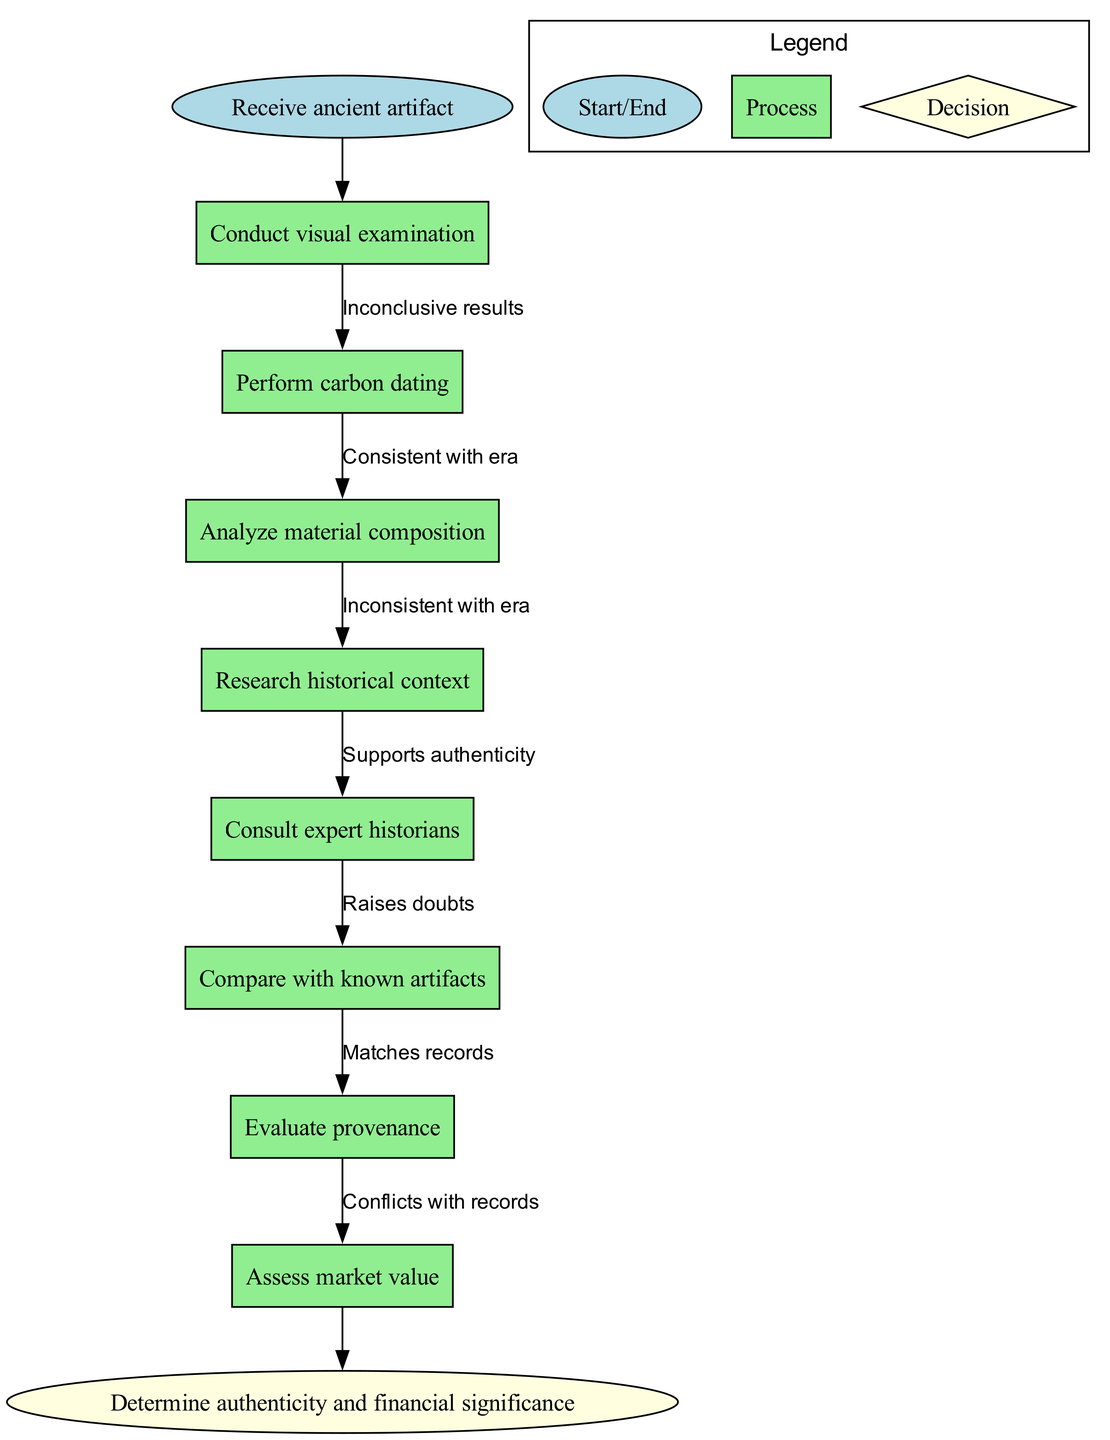What is the first step in the process? The first step in the process is indicated by the start node, which states "Receive ancient artifact." It is the initial action before any analysis can begin.
Answer: Receive ancient artifact How many process nodes are there? By counting the nodes listed in the diagram, we find eight process nodes. Each process represents a different aspect of the research methodology necessary for authenticating artifacts.
Answer: 8 What edges connect "Conduct visual examination" to "Perform carbon dating"? The edges show the relationship between nodes; however, in this flowchart, there is a direct connection from "Conduct visual examination" to the next process "Perform carbon dating" without a labeled edge because it follows consecutively in the steps. Thus, we infer it's a straightforward transition in the procedure.
Answer: Direct connection What would indicate "Inconsistent with era" in the flowchart? The term "Inconsistent with era" appears as an edge label that connects the nodes. It's part of the decision-making process where findings from an analysis raise doubts about the artifact's authenticity.
Answer: Inconsistent with era If the analysis "Raises doubts," which node does the flow lead to next? The flow from "Raises doubts" would typically lead to "Evaluate provenance," as it suggests further scrutiny of the artifact's background is necessary to determine authenticity, due to inconsistencies found.
Answer: Evaluate provenance What is the final outcome depicted in the flowchart? The final outcome node represents the concluding step in the authentication process, described as "Determine authenticity and financial significance." It is the end goal after thorough research and analysis.
Answer: Determine authenticity and financial significance Which nodes appear to involve assessments related to expert involvement? The nodes "Consult expert historians" and "Evaluate provenance" indicate assessments that involve the expertise of historians and provenance analysis to strengthen the authentication process.
Answer: Consult expert historians, Evaluate provenance What kind of relationship do "Matches records" and "Conflicts with records" depict? These phrases represent edges that reflect outcomes from comparing historical documentation with the artifact's features. They suggest a decision-making process where findings may validate or question authenticity based on historical records.
Answer: Outcomes of comparison What does the diagram suggest follows after a "High confidence" evaluation? Following a "High confidence" evaluation, the flow leads to the final step, which is to "Determine authenticity and financial significance," indicating a positive affirmation of the artifact's authenticity leading to its financial evaluation.
Answer: Determine authenticity and financial significance 